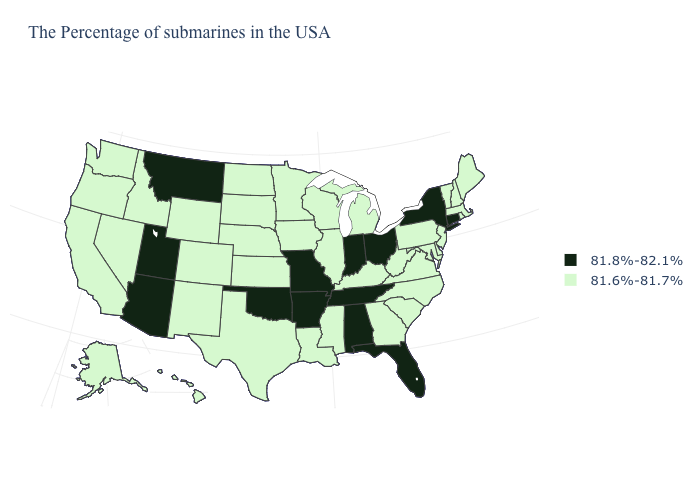Among the states that border New Mexico , which have the lowest value?
Write a very short answer. Texas, Colorado. Does Hawaii have the same value as Delaware?
Give a very brief answer. Yes. What is the highest value in the USA?
Short answer required. 81.8%-82.1%. Does the map have missing data?
Write a very short answer. No. Does Nevada have the lowest value in the USA?
Write a very short answer. Yes. What is the value of Georgia?
Short answer required. 81.6%-81.7%. What is the highest value in states that border Indiana?
Be succinct. 81.8%-82.1%. Which states hav the highest value in the Northeast?
Keep it brief. Connecticut, New York. Does Oklahoma have the highest value in the USA?
Give a very brief answer. Yes. Among the states that border North Carolina , which have the highest value?
Keep it brief. Tennessee. What is the value of Nevada?
Short answer required. 81.6%-81.7%. What is the value of New Jersey?
Keep it brief. 81.6%-81.7%. What is the lowest value in the Northeast?
Quick response, please. 81.6%-81.7%. Does Missouri have the same value as Pennsylvania?
Be succinct. No. Name the states that have a value in the range 81.8%-82.1%?
Write a very short answer. Connecticut, New York, Ohio, Florida, Indiana, Alabama, Tennessee, Missouri, Arkansas, Oklahoma, Utah, Montana, Arizona. 